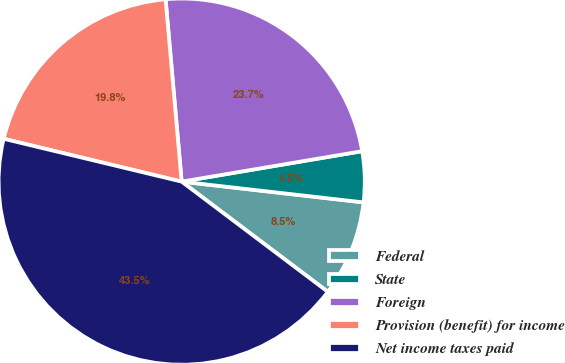Convert chart. <chart><loc_0><loc_0><loc_500><loc_500><pie_chart><fcel>Federal<fcel>State<fcel>Foreign<fcel>Provision (benefit) for income<fcel>Net income taxes paid<nl><fcel>8.47%<fcel>4.47%<fcel>23.74%<fcel>19.84%<fcel>43.48%<nl></chart> 